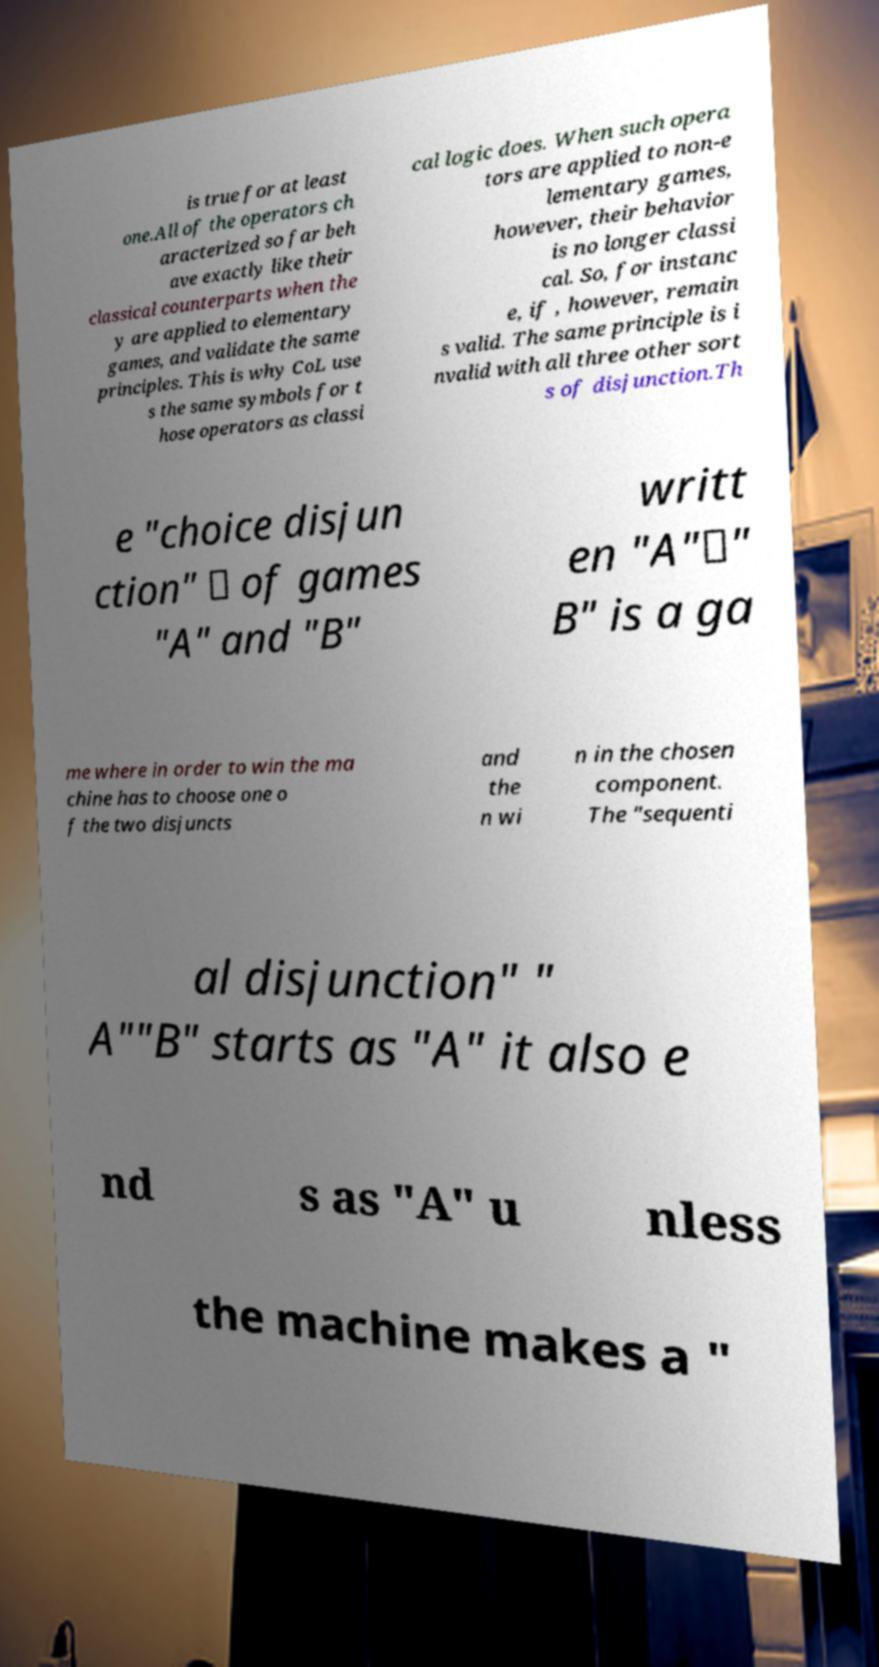Could you assist in decoding the text presented in this image and type it out clearly? is true for at least one.All of the operators ch aracterized so far beh ave exactly like their classical counterparts when the y are applied to elementary games, and validate the same principles. This is why CoL use s the same symbols for t hose operators as classi cal logic does. When such opera tors are applied to non-e lementary games, however, their behavior is no longer classi cal. So, for instanc e, if , however, remain s valid. The same principle is i nvalid with all three other sort s of disjunction.Th e "choice disjun ction" ⊔ of games "A" and "B" writt en "A"⊔" B" is a ga me where in order to win the ma chine has to choose one o f the two disjuncts and the n wi n in the chosen component. The "sequenti al disjunction" " A""B" starts as "A" it also e nd s as "A" u nless the machine makes a " 